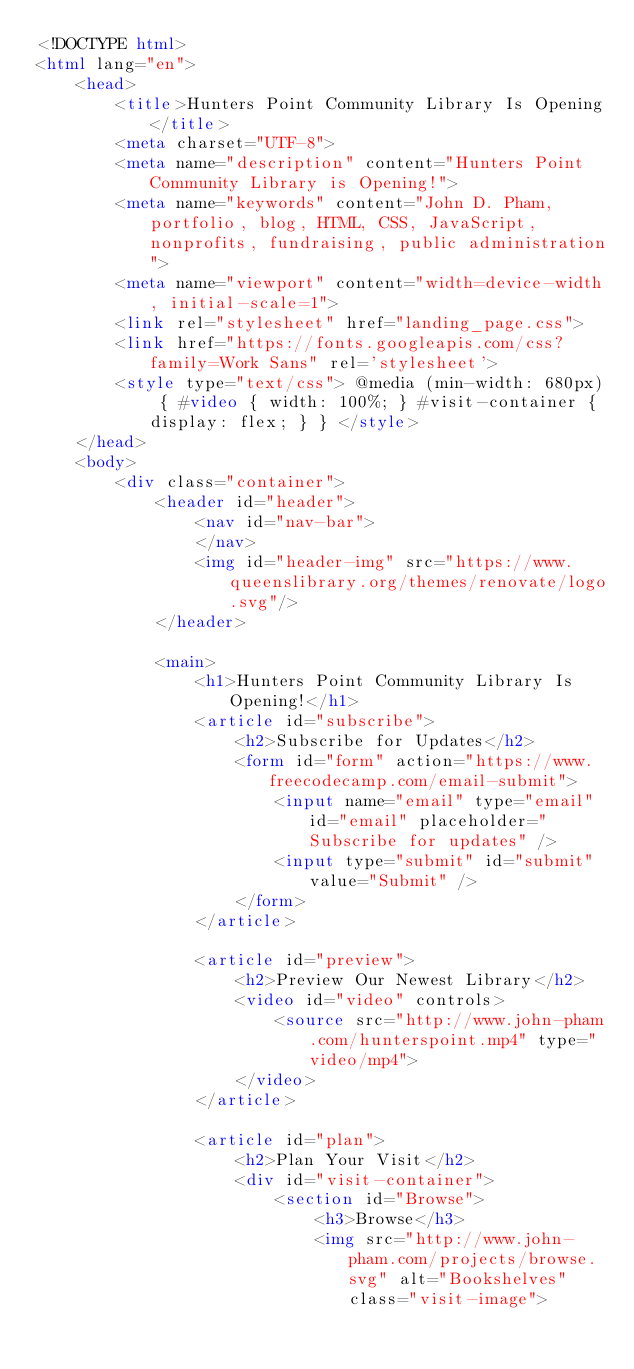Convert code to text. <code><loc_0><loc_0><loc_500><loc_500><_HTML_><!DOCTYPE html>
<html lang="en">
    <head>
        <title>Hunters Point Community Library Is Opening</title>
        <meta charset="UTF-8">
        <meta name="description" content="Hunters Point Community Library is Opening!">
        <meta name="keywords" content="John D. Pham, portfolio, blog, HTML, CSS, JavaScript, nonprofits, fundraising, public administration">
        <meta name="viewport" content="width=device-width, initial-scale=1">
        <link rel="stylesheet" href="landing_page.css">
        <link href="https://fonts.googleapis.com/css?family=Work Sans" rel='stylesheet'>
        <style type="text/css"> @media (min-width: 680px) { #video { width: 100%; } #visit-container {display: flex; } } </style> 
    </head>
    <body>
        <div class="container">
            <header id="header">
                <nav id="nav-bar">
                </nav>
                <img id="header-img" src="https://www.queenslibrary.org/themes/renovate/logo.svg"/>
            </header>
            
            <main>
                <h1>Hunters Point Community Library Is Opening!</h1>
                <article id="subscribe">
                    <h2>Subscribe for Updates</h2>
                    <form id="form" action="https://www.freecodecamp.com/email-submit">
                        <input name="email" type="email" id="email" placeholder="Subscribe for updates" />
                        <input type="submit" id="submit" value="Submit" />
                    </form>
                </article>

                <article id="preview">
                    <h2>Preview Our Newest Library</h2>
                    <video id="video" controls>
                        <source src="http://www.john-pham.com/hunterspoint.mp4" type="video/mp4">
                    </video>
                </article>

                <article id="plan">
                    <h2>Plan Your Visit</h2>
                    <div id="visit-container">
                        <section id="Browse">
                            <h3>Browse</h3>
                            <img src="http://www.john-pham.com/projects/browse.svg" alt="Bookshelves" class="visit-image"></code> 